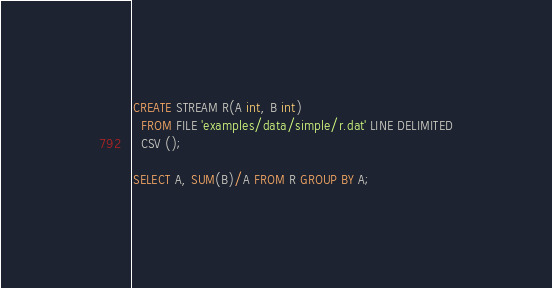<code> <loc_0><loc_0><loc_500><loc_500><_SQL_>CREATE STREAM R(A int, B int) 
  FROM FILE 'examples/data/simple/r.dat' LINE DELIMITED
  CSV ();

SELECT A, SUM(B)/A FROM R GROUP BY A;
</code> 